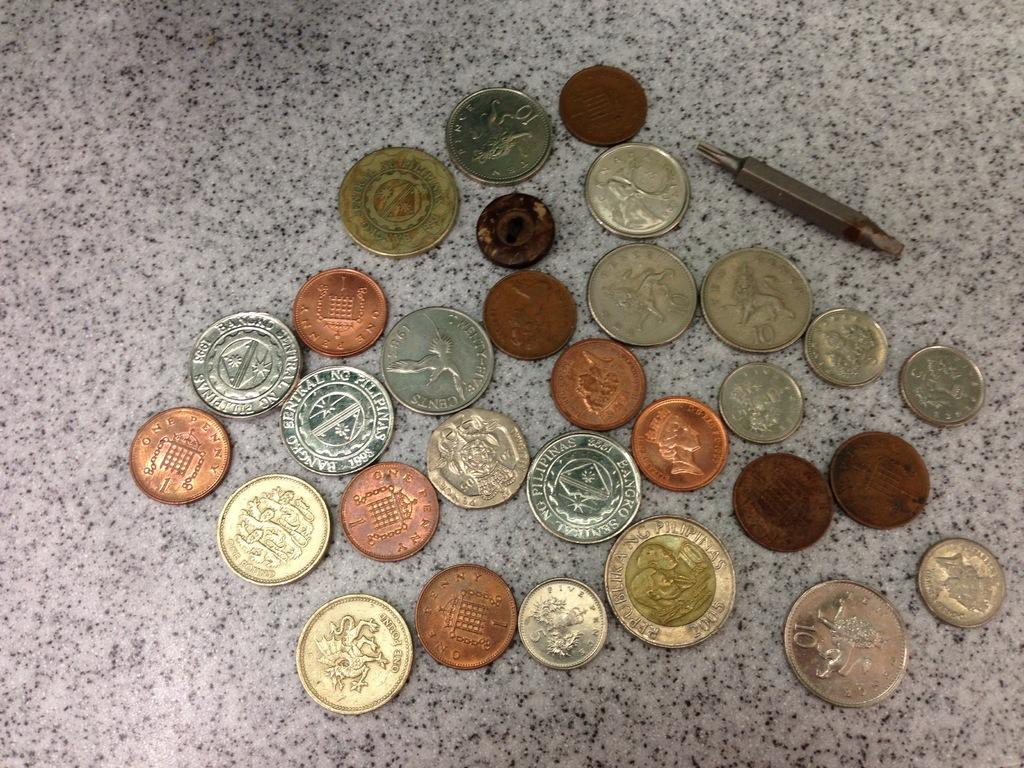<image>
Describe the image concisely. Several coins, including a one pound piece, are laid out. 